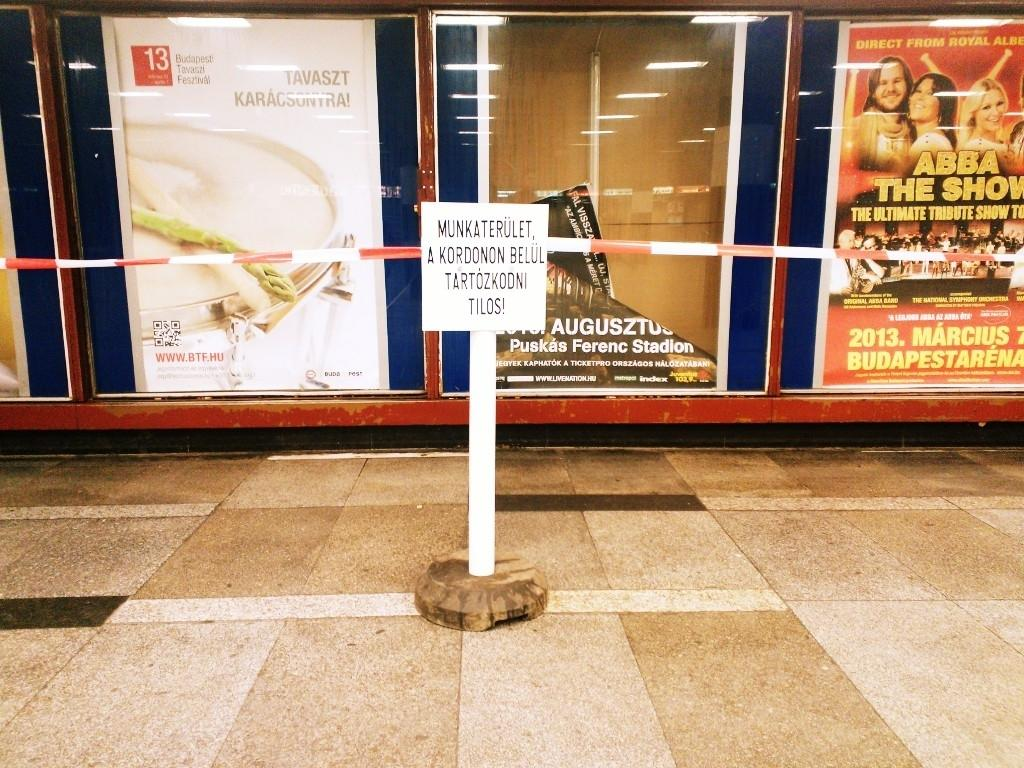Provide a one-sentence caption for the provided image. A sign in a foreign language stands in front of an Abba poster. 